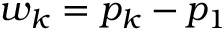<formula> <loc_0><loc_0><loc_500><loc_500>w _ { k } = p _ { k } - p _ { 1 }</formula> 